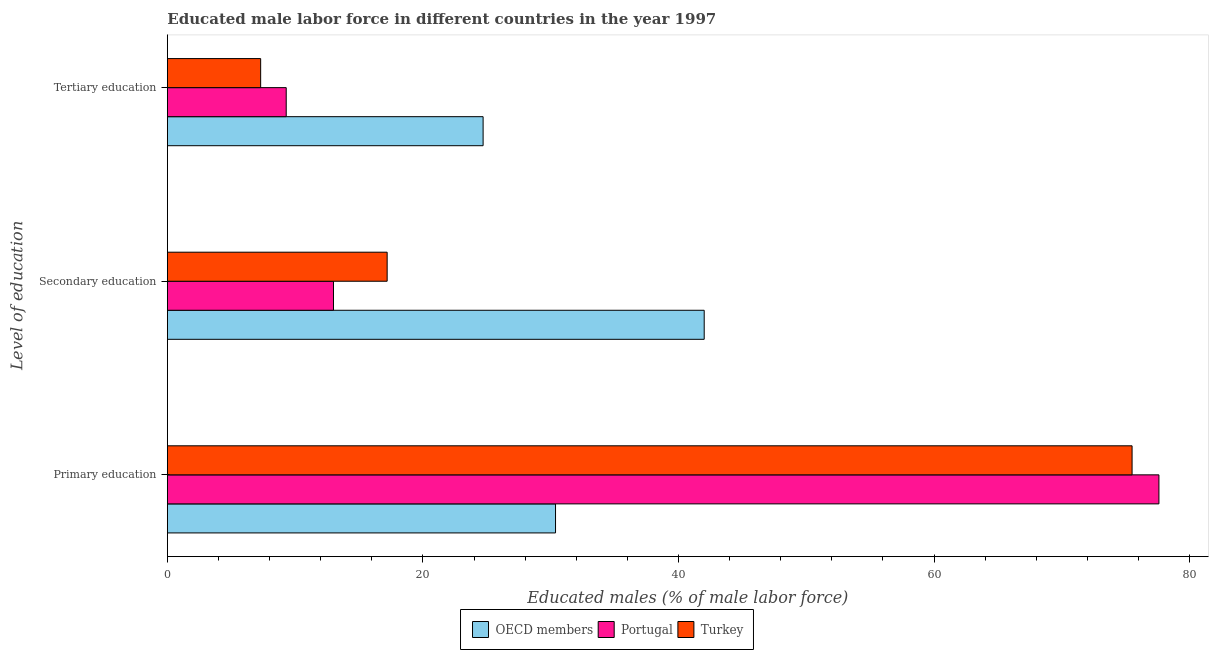How many different coloured bars are there?
Your response must be concise. 3. How many groups of bars are there?
Your answer should be compact. 3. Are the number of bars per tick equal to the number of legend labels?
Provide a short and direct response. Yes. Are the number of bars on each tick of the Y-axis equal?
Offer a terse response. Yes. What is the percentage of male labor force who received secondary education in OECD members?
Your response must be concise. 42.01. Across all countries, what is the maximum percentage of male labor force who received secondary education?
Make the answer very short. 42.01. Across all countries, what is the minimum percentage of male labor force who received tertiary education?
Offer a terse response. 7.3. In which country was the percentage of male labor force who received primary education maximum?
Offer a terse response. Portugal. In which country was the percentage of male labor force who received tertiary education minimum?
Keep it short and to the point. Turkey. What is the total percentage of male labor force who received primary education in the graph?
Make the answer very short. 183.48. What is the difference between the percentage of male labor force who received primary education in Portugal and that in OECD members?
Keep it short and to the point. 47.22. What is the difference between the percentage of male labor force who received primary education in Portugal and the percentage of male labor force who received secondary education in OECD members?
Your answer should be compact. 35.59. What is the average percentage of male labor force who received tertiary education per country?
Give a very brief answer. 13.77. What is the difference between the percentage of male labor force who received primary education and percentage of male labor force who received tertiary education in Portugal?
Offer a terse response. 68.3. In how many countries, is the percentage of male labor force who received primary education greater than 36 %?
Your answer should be compact. 2. What is the ratio of the percentage of male labor force who received tertiary education in OECD members to that in Turkey?
Your answer should be compact. 3.38. Is the difference between the percentage of male labor force who received primary education in Portugal and OECD members greater than the difference between the percentage of male labor force who received secondary education in Portugal and OECD members?
Your response must be concise. Yes. What is the difference between the highest and the second highest percentage of male labor force who received primary education?
Your answer should be very brief. 2.1. What is the difference between the highest and the lowest percentage of male labor force who received tertiary education?
Provide a short and direct response. 17.41. In how many countries, is the percentage of male labor force who received secondary education greater than the average percentage of male labor force who received secondary education taken over all countries?
Ensure brevity in your answer.  1. Is the sum of the percentage of male labor force who received tertiary education in Portugal and OECD members greater than the maximum percentage of male labor force who received primary education across all countries?
Make the answer very short. No. What does the 1st bar from the top in Primary education represents?
Offer a very short reply. Turkey. What does the 3rd bar from the bottom in Primary education represents?
Give a very brief answer. Turkey. Is it the case that in every country, the sum of the percentage of male labor force who received primary education and percentage of male labor force who received secondary education is greater than the percentage of male labor force who received tertiary education?
Offer a very short reply. Yes. What is the difference between two consecutive major ticks on the X-axis?
Your answer should be compact. 20. Does the graph contain grids?
Make the answer very short. No. Where does the legend appear in the graph?
Give a very brief answer. Bottom center. How are the legend labels stacked?
Your response must be concise. Horizontal. What is the title of the graph?
Your answer should be compact. Educated male labor force in different countries in the year 1997. Does "New Zealand" appear as one of the legend labels in the graph?
Make the answer very short. No. What is the label or title of the X-axis?
Your response must be concise. Educated males (% of male labor force). What is the label or title of the Y-axis?
Give a very brief answer. Level of education. What is the Educated males (% of male labor force) in OECD members in Primary education?
Your response must be concise. 30.38. What is the Educated males (% of male labor force) of Portugal in Primary education?
Offer a very short reply. 77.6. What is the Educated males (% of male labor force) of Turkey in Primary education?
Keep it short and to the point. 75.5. What is the Educated males (% of male labor force) in OECD members in Secondary education?
Your answer should be compact. 42.01. What is the Educated males (% of male labor force) of Turkey in Secondary education?
Your answer should be compact. 17.2. What is the Educated males (% of male labor force) in OECD members in Tertiary education?
Ensure brevity in your answer.  24.71. What is the Educated males (% of male labor force) in Portugal in Tertiary education?
Your answer should be very brief. 9.3. What is the Educated males (% of male labor force) of Turkey in Tertiary education?
Your response must be concise. 7.3. Across all Level of education, what is the maximum Educated males (% of male labor force) of OECD members?
Offer a terse response. 42.01. Across all Level of education, what is the maximum Educated males (% of male labor force) in Portugal?
Make the answer very short. 77.6. Across all Level of education, what is the maximum Educated males (% of male labor force) in Turkey?
Provide a short and direct response. 75.5. Across all Level of education, what is the minimum Educated males (% of male labor force) of OECD members?
Your answer should be very brief. 24.71. Across all Level of education, what is the minimum Educated males (% of male labor force) of Portugal?
Provide a succinct answer. 9.3. Across all Level of education, what is the minimum Educated males (% of male labor force) in Turkey?
Your answer should be very brief. 7.3. What is the total Educated males (% of male labor force) in OECD members in the graph?
Your answer should be compact. 97.1. What is the total Educated males (% of male labor force) of Portugal in the graph?
Ensure brevity in your answer.  99.9. What is the total Educated males (% of male labor force) of Turkey in the graph?
Offer a terse response. 100. What is the difference between the Educated males (% of male labor force) in OECD members in Primary education and that in Secondary education?
Make the answer very short. -11.64. What is the difference between the Educated males (% of male labor force) of Portugal in Primary education and that in Secondary education?
Provide a succinct answer. 64.6. What is the difference between the Educated males (% of male labor force) of Turkey in Primary education and that in Secondary education?
Keep it short and to the point. 58.3. What is the difference between the Educated males (% of male labor force) of OECD members in Primary education and that in Tertiary education?
Offer a very short reply. 5.67. What is the difference between the Educated males (% of male labor force) in Portugal in Primary education and that in Tertiary education?
Ensure brevity in your answer.  68.3. What is the difference between the Educated males (% of male labor force) in Turkey in Primary education and that in Tertiary education?
Provide a short and direct response. 68.2. What is the difference between the Educated males (% of male labor force) of OECD members in Secondary education and that in Tertiary education?
Ensure brevity in your answer.  17.3. What is the difference between the Educated males (% of male labor force) in Turkey in Secondary education and that in Tertiary education?
Ensure brevity in your answer.  9.9. What is the difference between the Educated males (% of male labor force) of OECD members in Primary education and the Educated males (% of male labor force) of Portugal in Secondary education?
Provide a succinct answer. 17.38. What is the difference between the Educated males (% of male labor force) of OECD members in Primary education and the Educated males (% of male labor force) of Turkey in Secondary education?
Ensure brevity in your answer.  13.18. What is the difference between the Educated males (% of male labor force) of Portugal in Primary education and the Educated males (% of male labor force) of Turkey in Secondary education?
Your answer should be compact. 60.4. What is the difference between the Educated males (% of male labor force) in OECD members in Primary education and the Educated males (% of male labor force) in Portugal in Tertiary education?
Provide a succinct answer. 21.08. What is the difference between the Educated males (% of male labor force) in OECD members in Primary education and the Educated males (% of male labor force) in Turkey in Tertiary education?
Provide a succinct answer. 23.08. What is the difference between the Educated males (% of male labor force) of Portugal in Primary education and the Educated males (% of male labor force) of Turkey in Tertiary education?
Provide a short and direct response. 70.3. What is the difference between the Educated males (% of male labor force) in OECD members in Secondary education and the Educated males (% of male labor force) in Portugal in Tertiary education?
Offer a terse response. 32.71. What is the difference between the Educated males (% of male labor force) in OECD members in Secondary education and the Educated males (% of male labor force) in Turkey in Tertiary education?
Make the answer very short. 34.71. What is the average Educated males (% of male labor force) in OECD members per Level of education?
Your answer should be very brief. 32.37. What is the average Educated males (% of male labor force) of Portugal per Level of education?
Give a very brief answer. 33.3. What is the average Educated males (% of male labor force) of Turkey per Level of education?
Offer a very short reply. 33.33. What is the difference between the Educated males (% of male labor force) in OECD members and Educated males (% of male labor force) in Portugal in Primary education?
Offer a terse response. -47.22. What is the difference between the Educated males (% of male labor force) of OECD members and Educated males (% of male labor force) of Turkey in Primary education?
Your answer should be compact. -45.12. What is the difference between the Educated males (% of male labor force) of Portugal and Educated males (% of male labor force) of Turkey in Primary education?
Ensure brevity in your answer.  2.1. What is the difference between the Educated males (% of male labor force) in OECD members and Educated males (% of male labor force) in Portugal in Secondary education?
Make the answer very short. 29.01. What is the difference between the Educated males (% of male labor force) of OECD members and Educated males (% of male labor force) of Turkey in Secondary education?
Offer a terse response. 24.81. What is the difference between the Educated males (% of male labor force) of OECD members and Educated males (% of male labor force) of Portugal in Tertiary education?
Provide a short and direct response. 15.41. What is the difference between the Educated males (% of male labor force) of OECD members and Educated males (% of male labor force) of Turkey in Tertiary education?
Give a very brief answer. 17.41. What is the difference between the Educated males (% of male labor force) in Portugal and Educated males (% of male labor force) in Turkey in Tertiary education?
Your answer should be compact. 2. What is the ratio of the Educated males (% of male labor force) in OECD members in Primary education to that in Secondary education?
Your answer should be compact. 0.72. What is the ratio of the Educated males (% of male labor force) of Portugal in Primary education to that in Secondary education?
Your response must be concise. 5.97. What is the ratio of the Educated males (% of male labor force) of Turkey in Primary education to that in Secondary education?
Make the answer very short. 4.39. What is the ratio of the Educated males (% of male labor force) of OECD members in Primary education to that in Tertiary education?
Offer a very short reply. 1.23. What is the ratio of the Educated males (% of male labor force) in Portugal in Primary education to that in Tertiary education?
Your answer should be very brief. 8.34. What is the ratio of the Educated males (% of male labor force) of Turkey in Primary education to that in Tertiary education?
Ensure brevity in your answer.  10.34. What is the ratio of the Educated males (% of male labor force) of OECD members in Secondary education to that in Tertiary education?
Provide a short and direct response. 1.7. What is the ratio of the Educated males (% of male labor force) of Portugal in Secondary education to that in Tertiary education?
Keep it short and to the point. 1.4. What is the ratio of the Educated males (% of male labor force) in Turkey in Secondary education to that in Tertiary education?
Your answer should be very brief. 2.36. What is the difference between the highest and the second highest Educated males (% of male labor force) in OECD members?
Make the answer very short. 11.64. What is the difference between the highest and the second highest Educated males (% of male labor force) in Portugal?
Your answer should be compact. 64.6. What is the difference between the highest and the second highest Educated males (% of male labor force) of Turkey?
Your response must be concise. 58.3. What is the difference between the highest and the lowest Educated males (% of male labor force) in OECD members?
Give a very brief answer. 17.3. What is the difference between the highest and the lowest Educated males (% of male labor force) in Portugal?
Your response must be concise. 68.3. What is the difference between the highest and the lowest Educated males (% of male labor force) in Turkey?
Ensure brevity in your answer.  68.2. 